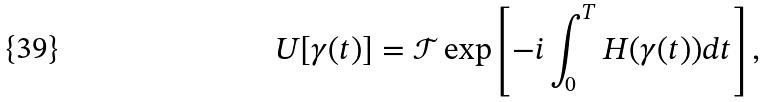<formula> <loc_0><loc_0><loc_500><loc_500>U [ \gamma ( t ) ] = { \mathcal { T } } \exp \left [ - i \int _ { 0 } ^ { T } H ( \gamma ( t ) ) d t \right ] ,</formula> 